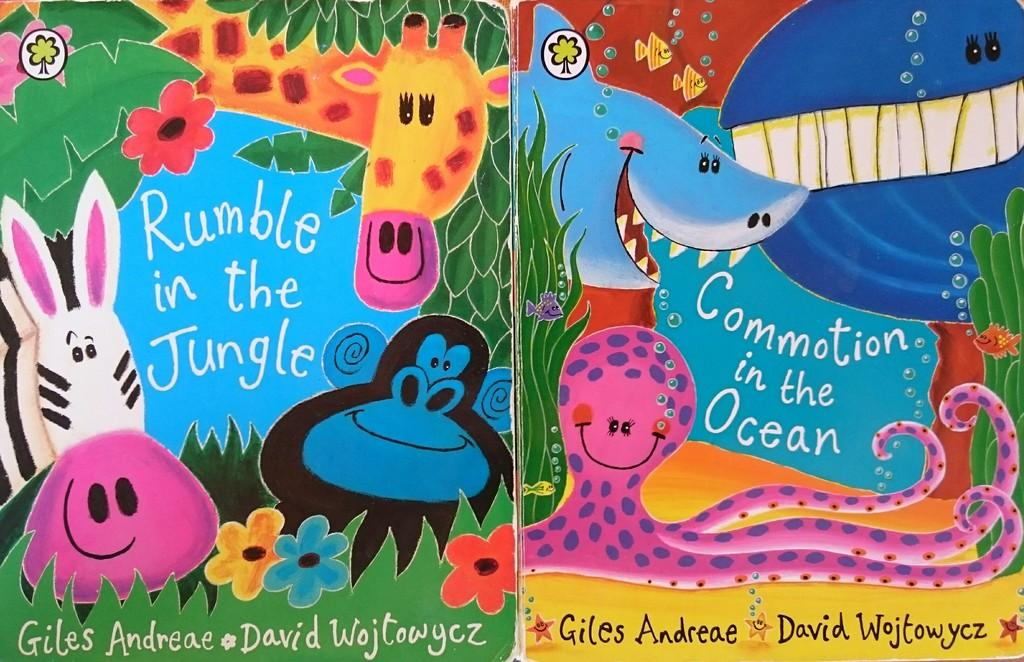What type of objects can be seen in the picture? There are books in the picture. What is depicted on the cover pages of the books? The cover pages of the books have cartoons on them. Can you describe the text in the middle of the picture? Yes, there is text in the middle of the picture. What is the location of the text at the bottom of the picture? There is text at the bottom of the picture. What type of beetle can be seen crawling on the border of the picture? There is no beetle present in the image, and there is no border depicted. 